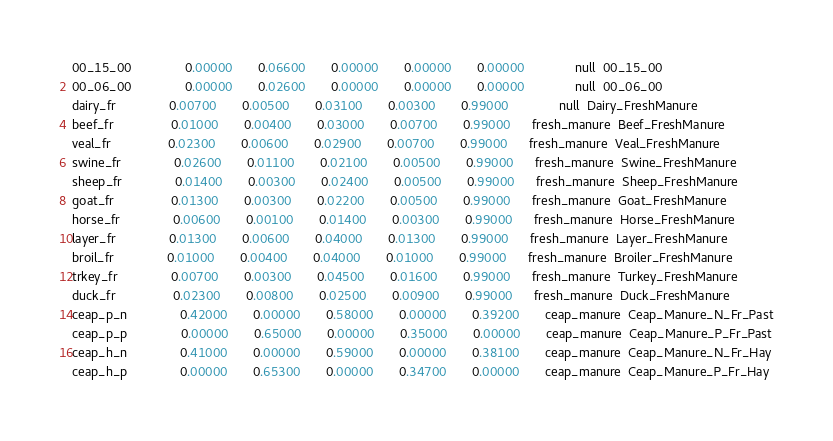Convert code to text. <code><loc_0><loc_0><loc_500><loc_500><_Forth_>00_15_00               0.00000       0.06600       0.00000       0.00000       0.00000              null  00_15_00
00_06_00               0.00000       0.02600       0.00000       0.00000       0.00000              null  00_06_00
dairy_fr               0.00700       0.00500       0.03100       0.00300       0.99000              null  Dairy_FreshManure
beef_fr                0.01000       0.00400       0.03000       0.00700       0.99000      fresh_manure  Beef_FreshManure
veal_fr                0.02300       0.00600       0.02900       0.00700       0.99000      fresh_manure  Veal_FreshManure
swine_fr               0.02600       0.01100       0.02100       0.00500       0.99000      fresh_manure  Swine_FreshManure
sheep_fr               0.01400       0.00300       0.02400       0.00500       0.99000      fresh_manure  Sheep_FreshManure
goat_fr                0.01300       0.00300       0.02200       0.00500       0.99000      fresh_manure  Goat_FreshManure
horse_fr               0.00600       0.00100       0.01400       0.00300       0.99000      fresh_manure  Horse_FreshManure
layer_fr               0.01300       0.00600       0.04000       0.01300       0.99000      fresh_manure  Layer_FreshManure
broil_fr               0.01000       0.00400       0.04000       0.01000       0.99000      fresh_manure  Broiler_FreshManure
trkey_fr               0.00700       0.00300       0.04500       0.01600       0.99000      fresh_manure  Turkey_FreshManure
duck_fr                0.02300       0.00800       0.02500       0.00900       0.99000      fresh_manure  Duck_FreshManure
ceap_p_n               0.42000       0.00000       0.58000       0.00000       0.39200       ceap_manure  Ceap_Manure_N_Fr_Past
ceap_p_p               0.00000       0.65000       0.00000       0.35000       0.00000       ceap_manure  Ceap_Manure_P_Fr_Past
ceap_h_n               0.41000       0.00000       0.59000       0.00000       0.38100       ceap_manure  Ceap_Manure_N_Fr_Hay
ceap_h_p               0.00000       0.65300       0.00000       0.34700       0.00000       ceap_manure  Ceap_Manure_P_Fr_Hay
</code> 